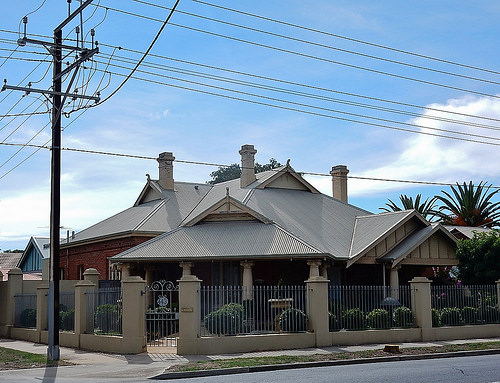<image>
Is there a house to the left of the electric post? No. The house is not to the left of the electric post. From this viewpoint, they have a different horizontal relationship. 